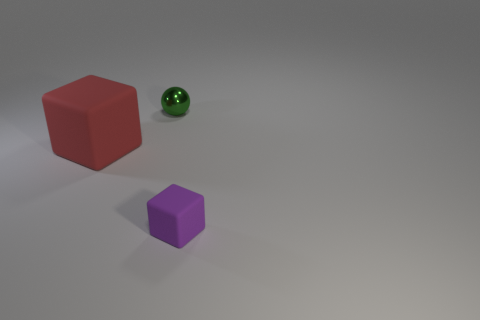Add 1 big things. How many objects exist? 4 Subtract all spheres. How many objects are left? 2 Subtract all small cubes. Subtract all small purple rubber objects. How many objects are left? 1 Add 1 tiny green things. How many tiny green things are left? 2 Add 1 yellow shiny cubes. How many yellow shiny cubes exist? 1 Subtract 0 red cylinders. How many objects are left? 3 